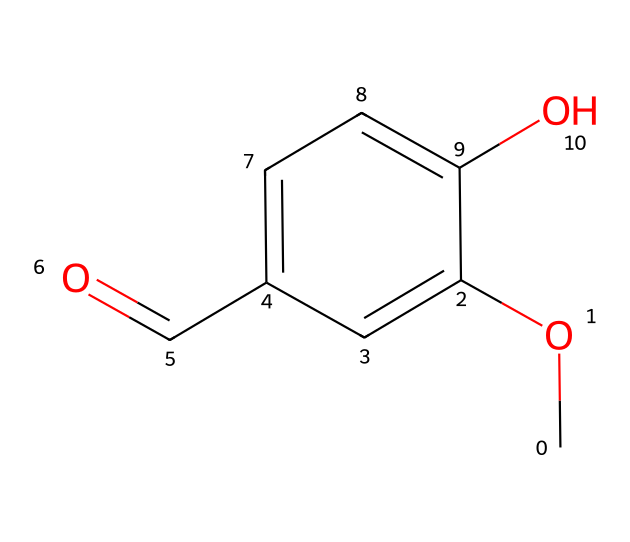What is the IUPAC name of this compound? The structure shows a methoxy (-OCH3) group attached to a phenolic framework with a formyl (-CHO) group. This combination indicates that the compound is Vanillin, which is derived from vanillin aldehyde.
Answer: Vanillin How many carbon atoms are present in this structure? The chemical structure contains a benzene ring with one methoxy group and one formyl group as substituents. Counting all the carbon atoms in the structure, there are eight in total.
Answer: 8 What functional groups can be identified in this compound? Examining the structure, we can see the presence of a methoxy group (-OCH3) and an aldehyde group (-CHO) attached to a benzene ring. These are characteristic functional groups present in this compound.
Answer: Methoxy and aldehyde Is the compound aromatic? The presence of a benzene ring in the structure indicates a system of delocalized electrons, which is a characteristic of aromatic compounds. Hence, this compound is indeed aromatic.
Answer: Yes What type of bond connects the carbon atoms in the benzene ring? The carbon atoms in the benzene ring are connected by alternating single and double bonds, which create resonance; this structure is a defining characteristic of aromatic compounds.
Answer: Alternating single and double bonds How does the presence of the methoxy group affect the compound's properties? The methoxy group is an electron-donating group, which can enhance the stability of the aromatic system and influence its reactivity, affecting how this compound interacts with its environment.
Answer: Electron-donating 